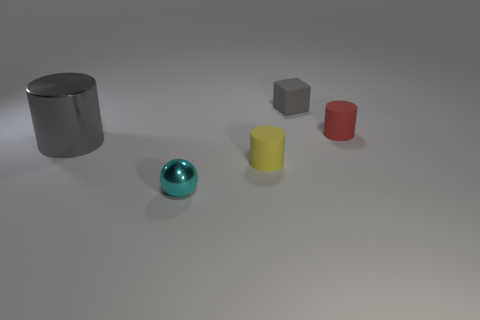Subtract all rubber cylinders. How many cylinders are left? 1 Add 4 shiny cylinders. How many objects exist? 9 Subtract all spheres. How many objects are left? 4 Add 1 red things. How many red things are left? 2 Add 1 gray matte objects. How many gray matte objects exist? 2 Subtract 0 gray balls. How many objects are left? 5 Subtract all blocks. Subtract all gray metallic cylinders. How many objects are left? 3 